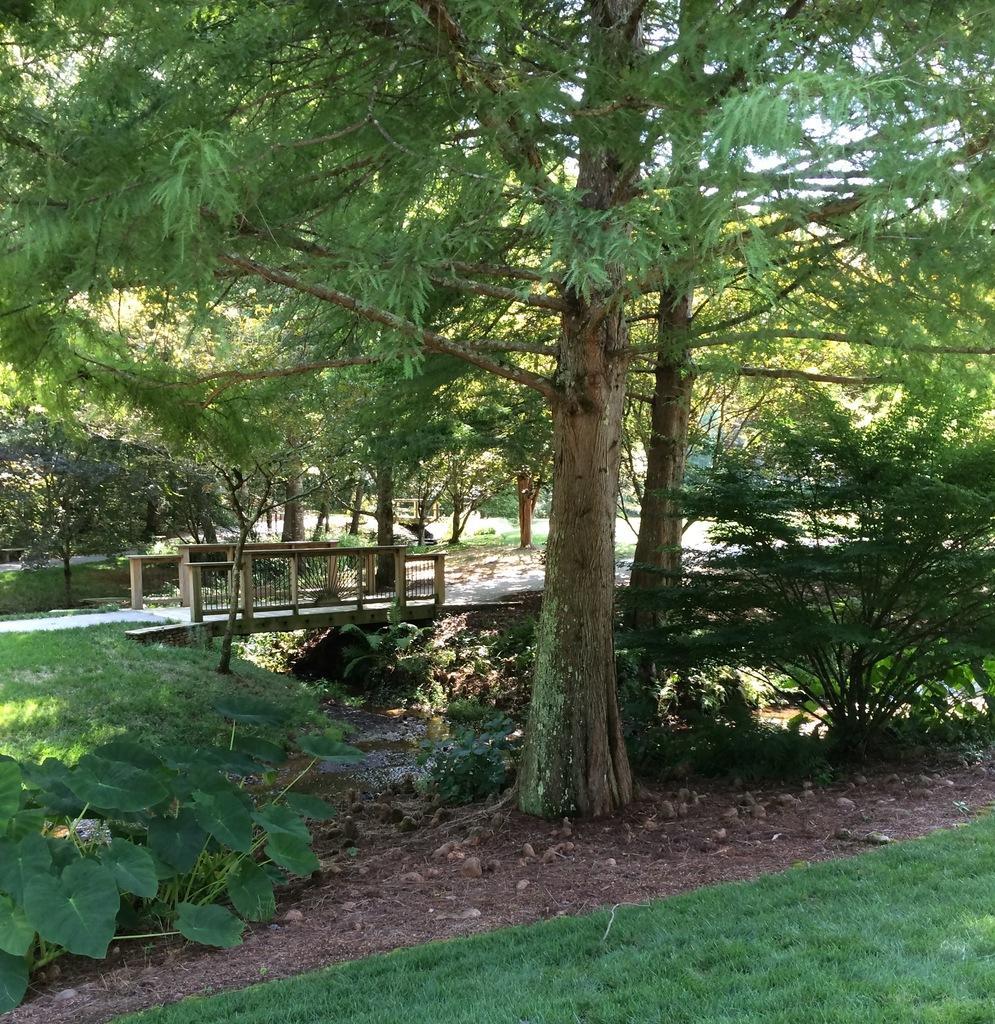In one or two sentences, can you explain what this image depicts? In the picture we can see the part of the grass surface and near it, we can see a muddy path with some plants and on it we can see some trees and behind it, we can see a path with railings and behind it also we can see a grass surface with some trees and from the trees we can see the part of the sky. 